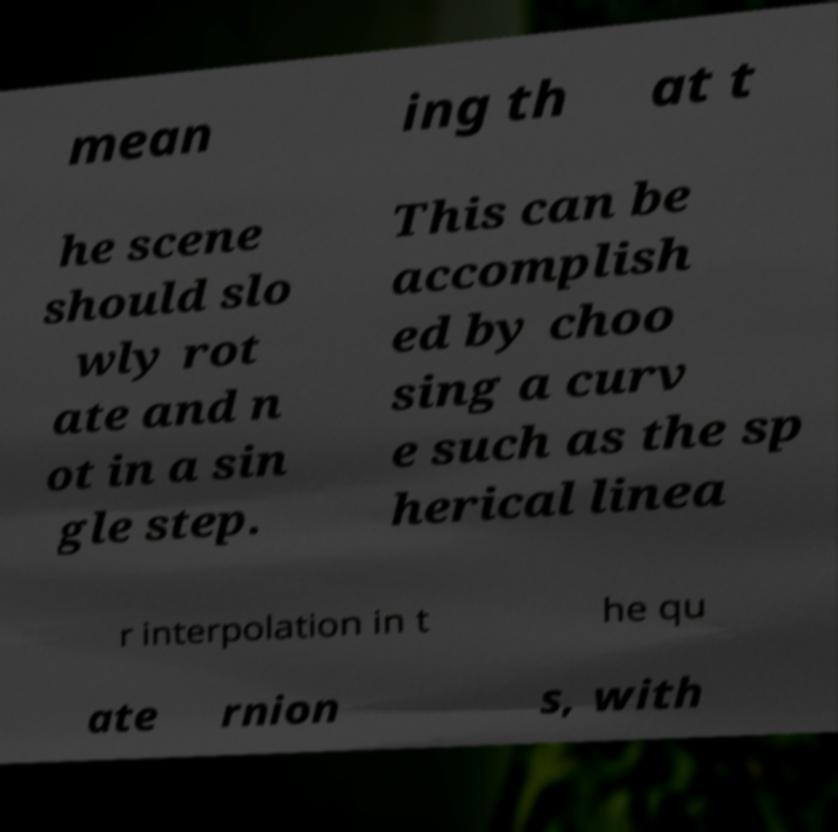Could you assist in decoding the text presented in this image and type it out clearly? mean ing th at t he scene should slo wly rot ate and n ot in a sin gle step. This can be accomplish ed by choo sing a curv e such as the sp herical linea r interpolation in t he qu ate rnion s, with 